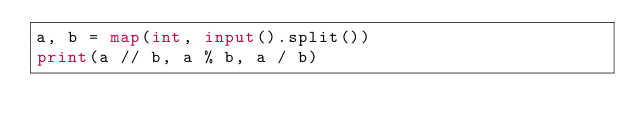Convert code to text. <code><loc_0><loc_0><loc_500><loc_500><_Python_>a, b = map(int, input().split())
print(a // b, a % b, a / b)</code> 